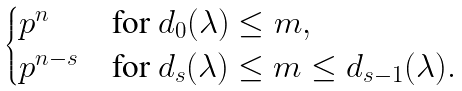Convert formula to latex. <formula><loc_0><loc_0><loc_500><loc_500>\begin{cases} p ^ { n } & \text {for $d_{0}(\lambda) \leq m,$} \\ p ^ { n - s } & \text {for $d_{s}(\lambda) \leq m \leq d_{s-1}(\lambda).$} \end{cases}</formula> 